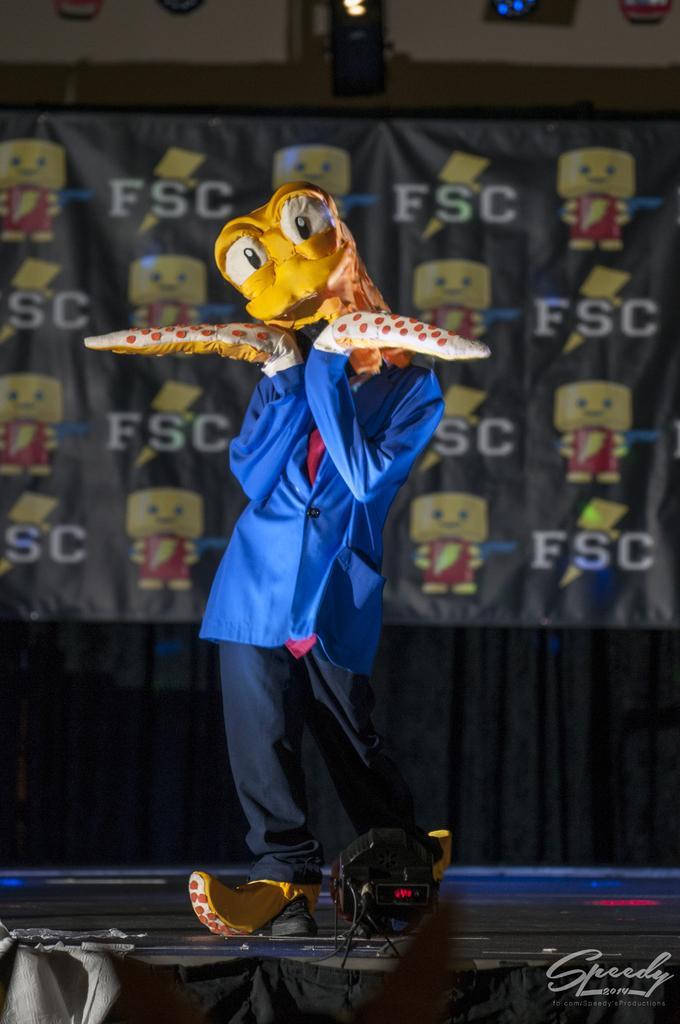Could you give a brief overview of what you see in this image? In this image I can see a person. In the background there is a curtain. 